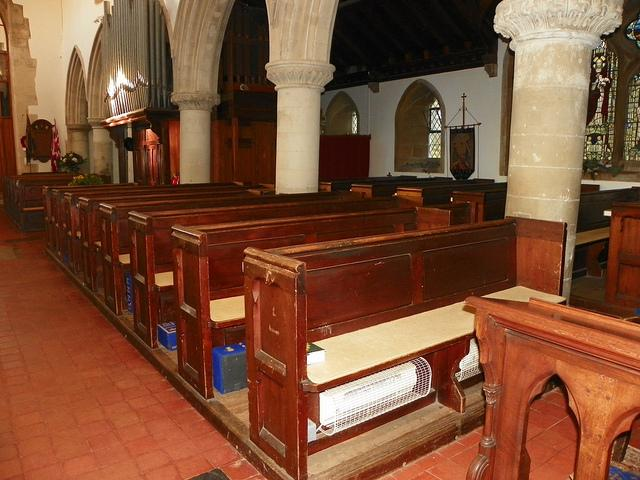What are the objects which are placed underneath the church pews? Please explain your reasoning. heaters. A heating/cooling device is visible in the lower back pew of this image; grating is placed around it to protect parishioners legs. 